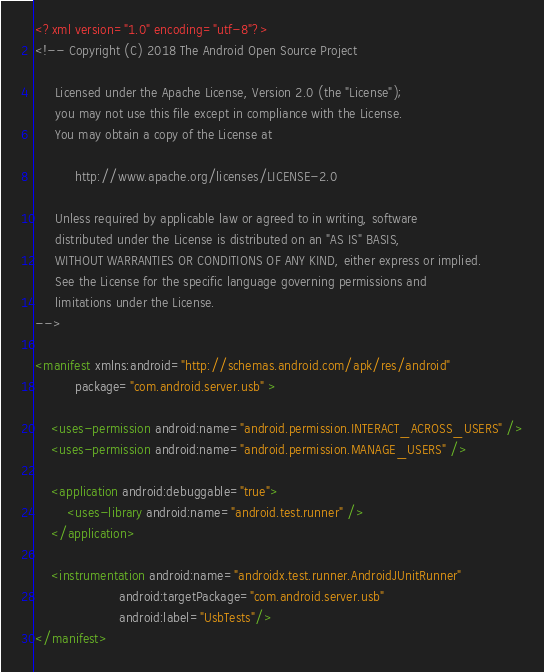Convert code to text. <code><loc_0><loc_0><loc_500><loc_500><_XML_><?xml version="1.0" encoding="utf-8"?>
<!-- Copyright (C) 2018 The Android Open Source Project

     Licensed under the Apache License, Version 2.0 (the "License");
     you may not use this file except in compliance with the License.
     You may obtain a copy of the License at

          http://www.apache.org/licenses/LICENSE-2.0

     Unless required by applicable law or agreed to in writing, software
     distributed under the License is distributed on an "AS IS" BASIS,
     WITHOUT WARRANTIES OR CONDITIONS OF ANY KIND, either express or implied.
     See the License for the specific language governing permissions and
     limitations under the License.
-->

<manifest xmlns:android="http://schemas.android.com/apk/res/android"
          package="com.android.server.usb" >

    <uses-permission android:name="android.permission.INTERACT_ACROSS_USERS" />
    <uses-permission android:name="android.permission.MANAGE_USERS" />

    <application android:debuggable="true">
        <uses-library android:name="android.test.runner" />
    </application>

    <instrumentation android:name="androidx.test.runner.AndroidJUnitRunner"
                     android:targetPackage="com.android.server.usb"
                     android:label="UsbTests"/>
</manifest>
</code> 